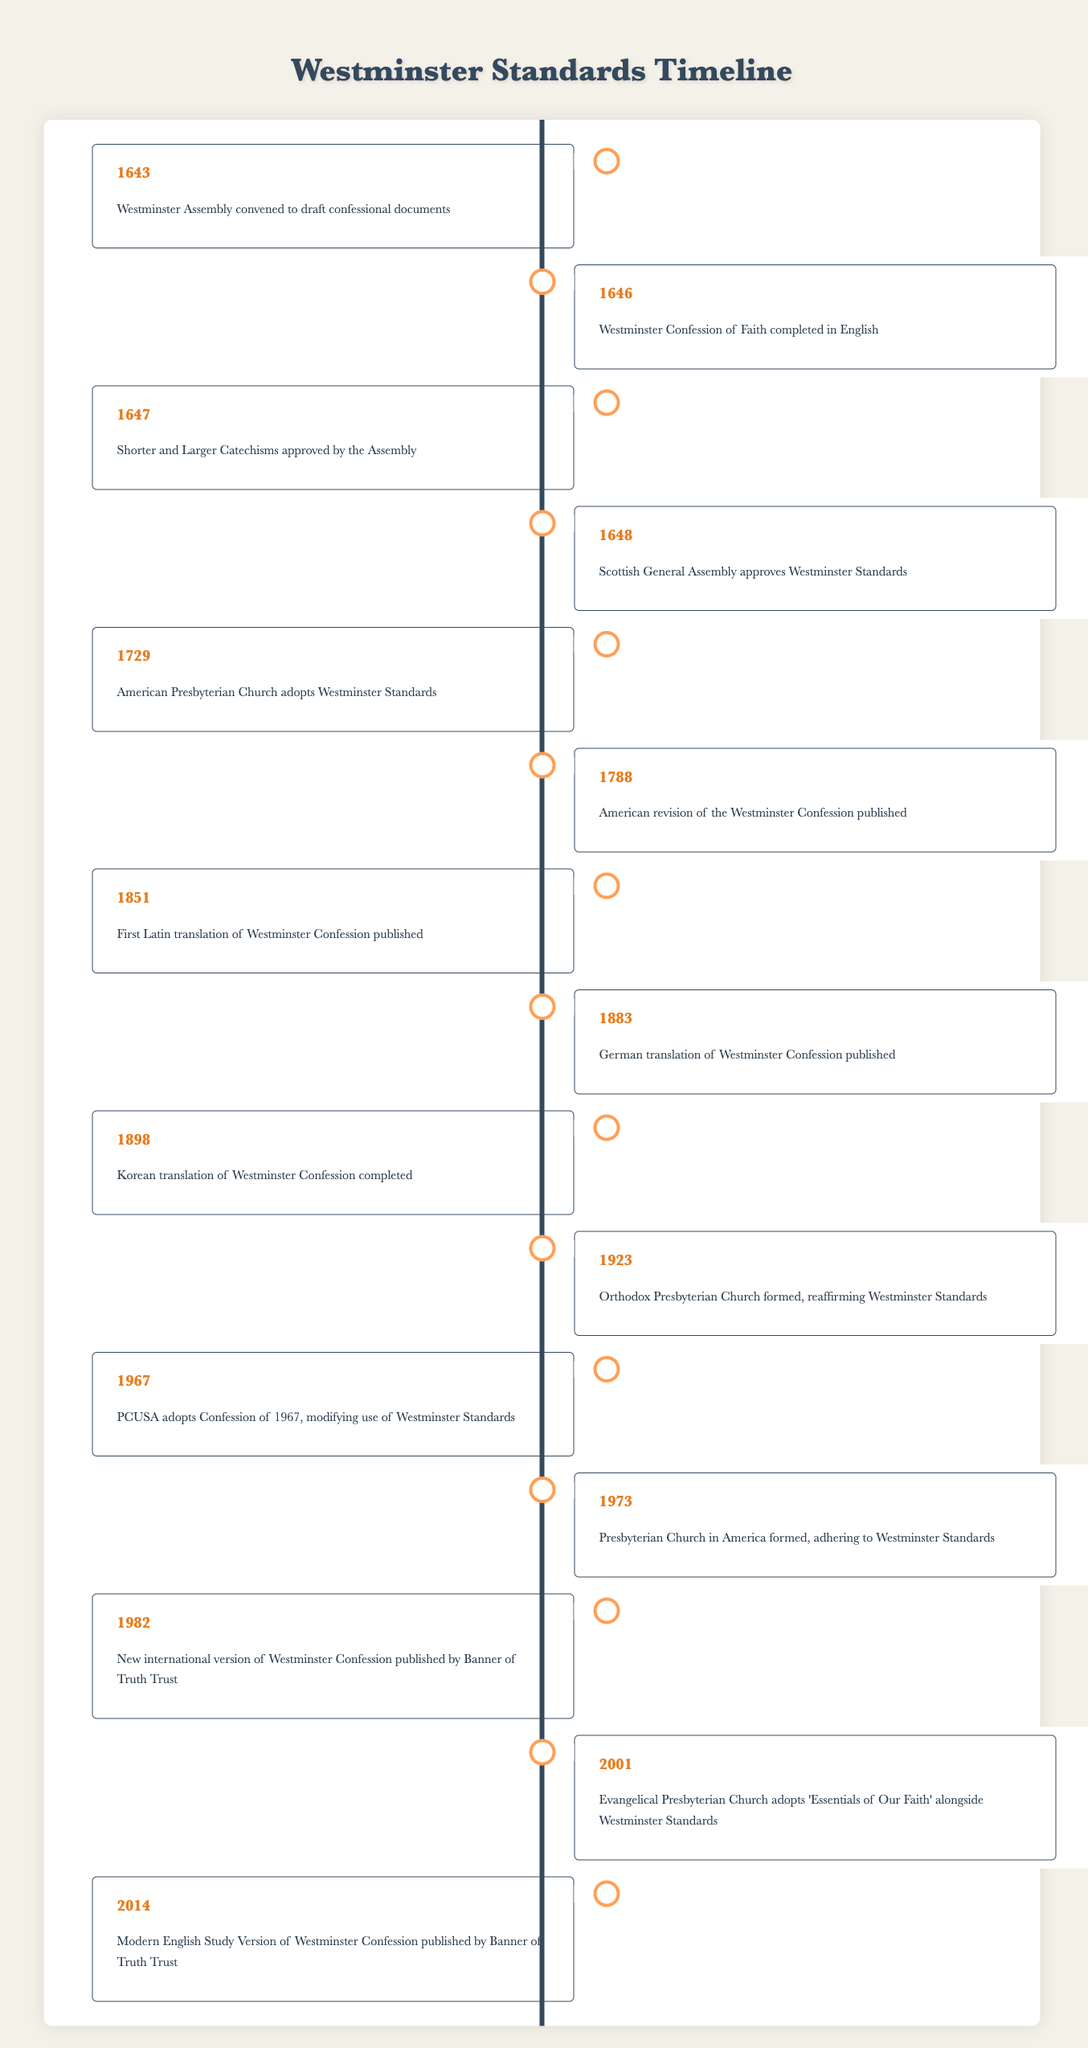What year was the Westminster Confession of Faith completed in English? The table specifically states that the Westminster Confession of Faith was completed in English in the year 1646.
Answer: 1646 Which event occurred first, the adoption of the Westminster Standards by the American Presbyterian Church or the first Latin translation of the Westminster Confession? According to the table, the American Presbyterian Church adopted the Westminster Standards in 1729, while the first Latin translation was published in 1851. Since 1729 is earlier than 1851, the adoption of the Westminster Standards occurred first.
Answer: The adoption occurred first How many years apart were the approvals of the Shorter and Larger Catechisms and the Scottish General Assembly's approval of the Westminster Standards? The Shorter and Larger Catechisms were approved in 1647, and the Scottish General Assembly approved the Westminster Standards in 1648. Therefore, the difference between the two years is 1648 - 1647 = 1 year.
Answer: 1 year True or False: The Korean translation of the Westminster Confession was completed before the formation of the Orthodox Presbyterian Church in 1923. The table indicates that the Korean translation was completed in 1898, and the Orthodox Presbyterian Church was formed in 1923. Since 1898 is earlier than 1923, the statement is true.
Answer: True What is the total number of milestones listed in the table related to the translation and publication history of the Westminster Standards? By counting the number of events listed in the table, there are 15 milestones, which are all significant in the timeline provided.
Answer: 15 What percentage of the events relate to the translation of the Westminster Confession? From the table, four events pertain specifically to translations of the Westminster Confession (Latin in 1851, German in 1883, Korean in 1898, and the modern English version in 2014), out of a total of 15 events. Thus, the percentage is (4/15) * 100 = 26.67%.
Answer: Approximately 26.67% What were the two milestones that occurred in the 1700s involving the Westminster Standards? The table shows that in the 1700s, the American Presbyterian Church adopted the Westminster Standards in 1729 and an American revision of the Westminster Confession was published in 1788.
Answer: The adoption in 1729 and the revision in 1788 How many events occurred during the 20th century? The table indicates events in the 20th century occurring in 1923 (Orthodox Presbyterian Church formed), 1967 (PCUSA modifies use), 1973 (Presbyterian Church in America formed), 1982 (new version published), 2001 (Evangelical Presbyterian Church adopts essentials), and 2014 (modern version published), totaling 6 events.
Answer: 6 events Was the adoption of the "Essentials of Our Faith" alongside Westminster Standards an event that happened before or after the PCUSA adopted the Confession of 1967? The table states that the PCUSA adopted the Confession of 1967 in 1967, while the Evangelical Presbyterian Church adopted 'Essentials of Our Faith' in 2001. Thus, the adoption of 'Essentials of Our Faith' occurred after the PCUSA action.
Answer: After 